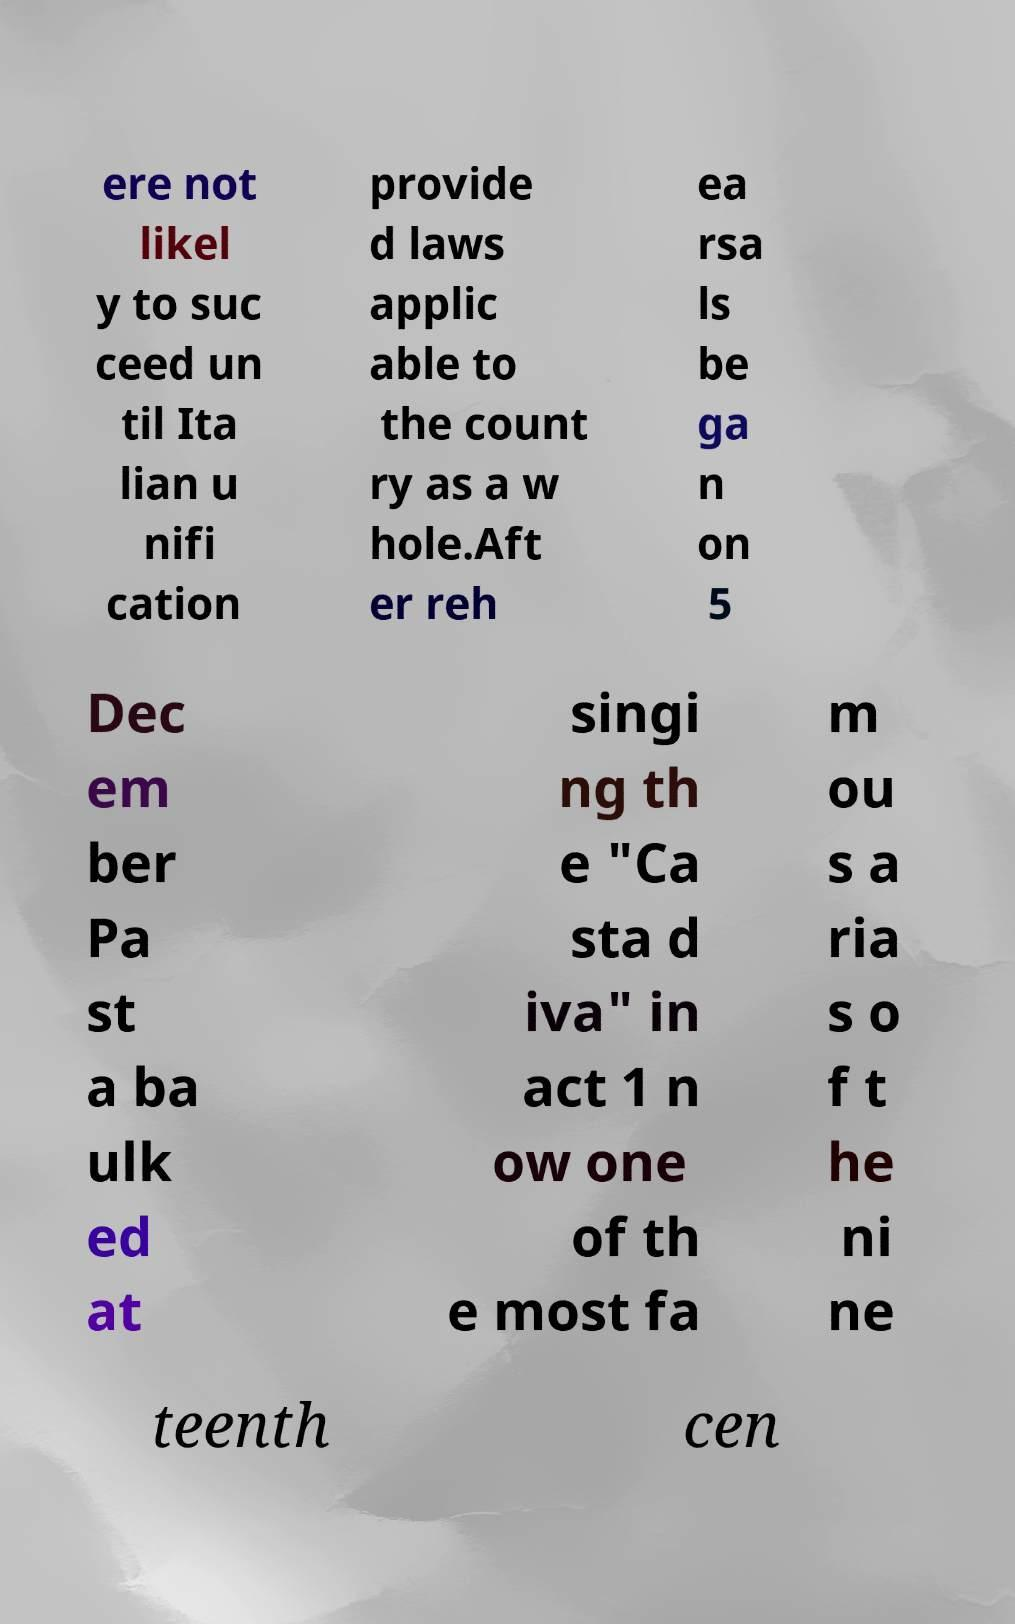For documentation purposes, I need the text within this image transcribed. Could you provide that? ere not likel y to suc ceed un til Ita lian u nifi cation provide d laws applic able to the count ry as a w hole.Aft er reh ea rsa ls be ga n on 5 Dec em ber Pa st a ba ulk ed at singi ng th e "Ca sta d iva" in act 1 n ow one of th e most fa m ou s a ria s o f t he ni ne teenth cen 